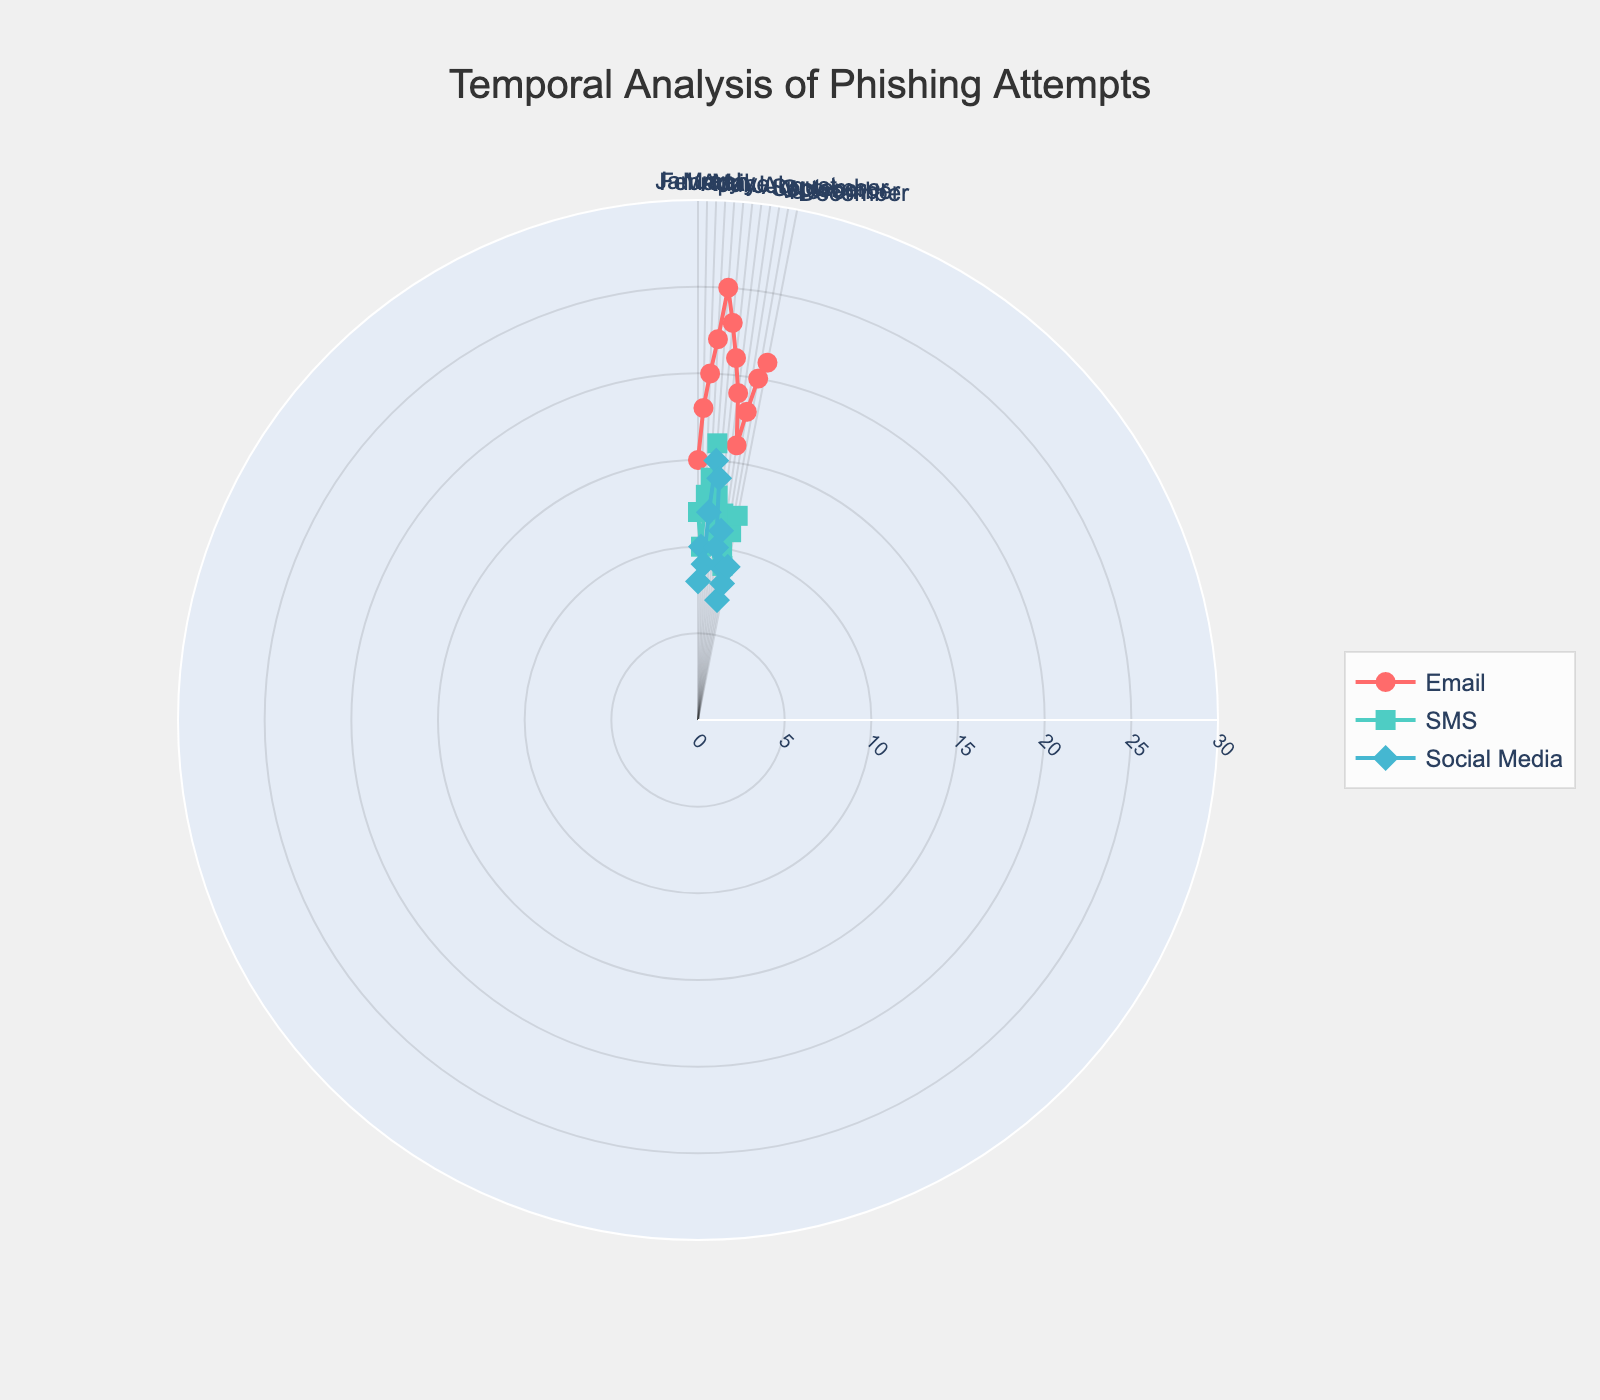What is the title of the chart? The title of the chart is prominently displayed at the top of the figure.
Answer: Temporal Analysis of Phishing Attempts Which month has the highest success rate for Email phishing? By looking at the radial values for the Email source, locate the highest point and check the corresponding month on the angular axis.
Answer: May What are the symbols used for each phishing source? The legend on the right side of the chart indicates the symbols. Circles are for Email, squares are for SMS, and diamonds are for Social Media.
Answer: Circles for Email, squares for SMS, diamonds for Social Media What is the average success rate of SMS phishing attempts from January to December? Sum the success rates for SMS across all months and divide by the number of months: (12+10+13+14+16+13+11+12+10+9+11+12)/12 = 11.92%.
Answer: 11.92% Which phishing source shows the most variability in success rate throughout the year? Compare the spread of success rates for each Phishing Source. Note which has the largest range between the highest and lowest values.
Answer: Email In which month do Social Media phishing attempts have the lowest success rate? Identify the lowest radial value for Social Media points and check the corresponding month on the angular axis.
Answer: October How many months have a success rate greater than 20% for Email phishing attempts? Count the months on the angular axis where the Email source has a radial value exceeding 20%.
Answer: 4 What is the success rate of SMS phishing in March? Find the radial value for the SMS source aligned with March on the angular axis.
Answer: 13% Compare the success rates of Email and Social Media phishing in April. Which one is higher? Look at the radial values of both sources for April and determine which one is higher.
Answer: Email Which month has the closest success rate between SMS and Social Media phishing attempts? Find the month where the radial distances for both SMS and Social Media are closest.
Answer: February 